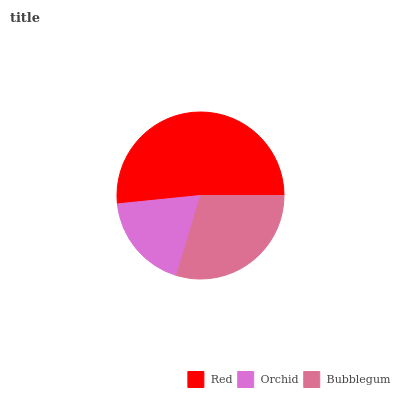Is Orchid the minimum?
Answer yes or no. Yes. Is Red the maximum?
Answer yes or no. Yes. Is Bubblegum the minimum?
Answer yes or no. No. Is Bubblegum the maximum?
Answer yes or no. No. Is Bubblegum greater than Orchid?
Answer yes or no. Yes. Is Orchid less than Bubblegum?
Answer yes or no. Yes. Is Orchid greater than Bubblegum?
Answer yes or no. No. Is Bubblegum less than Orchid?
Answer yes or no. No. Is Bubblegum the high median?
Answer yes or no. Yes. Is Bubblegum the low median?
Answer yes or no. Yes. Is Orchid the high median?
Answer yes or no. No. Is Red the low median?
Answer yes or no. No. 